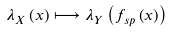<formula> <loc_0><loc_0><loc_500><loc_500>\lambda _ { X } \left ( x \right ) \longmapsto \lambda _ { Y } \left ( f _ { s p } \left ( x \right ) \right )</formula> 